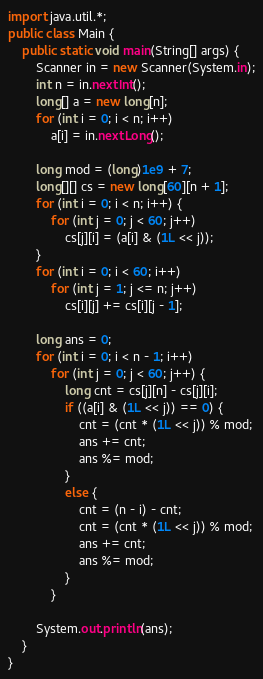Convert code to text. <code><loc_0><loc_0><loc_500><loc_500><_Java_>import java.util.*;
public class Main {
	public static void main(String[] args) {
		Scanner in = new Scanner(System.in);
		int n = in.nextInt();
		long[] a = new long[n];
		for (int i = 0; i < n; i++)
			a[i] = in.nextLong();

		long mod = (long)1e9 + 7;
		long[][] cs = new long[60][n + 1];
		for (int i = 0; i < n; i++) {
			for (int j = 0; j < 60; j++)
				cs[j][i] = (a[i] & (1L << j));
		}
		for (int i = 0; i < 60; i++)
			for (int j = 1; j <= n; j++)
				cs[i][j] += cs[i][j - 1];

		long ans = 0;
		for (int i = 0; i < n - 1; i++)
			for (int j = 0; j < 60; j++) {
				long cnt = cs[j][n] - cs[j][i];
				if ((a[i] & (1L << j)) == 0) {
					cnt = (cnt * (1L << j)) % mod;
					ans += cnt;
					ans %= mod;
				}
				else {
					cnt = (n - i) - cnt;
					cnt = (cnt * (1L << j)) % mod;
					ans += cnt;
					ans %= mod;
				}
			}
		
		System.out.println(ans);
	}
}
</code> 